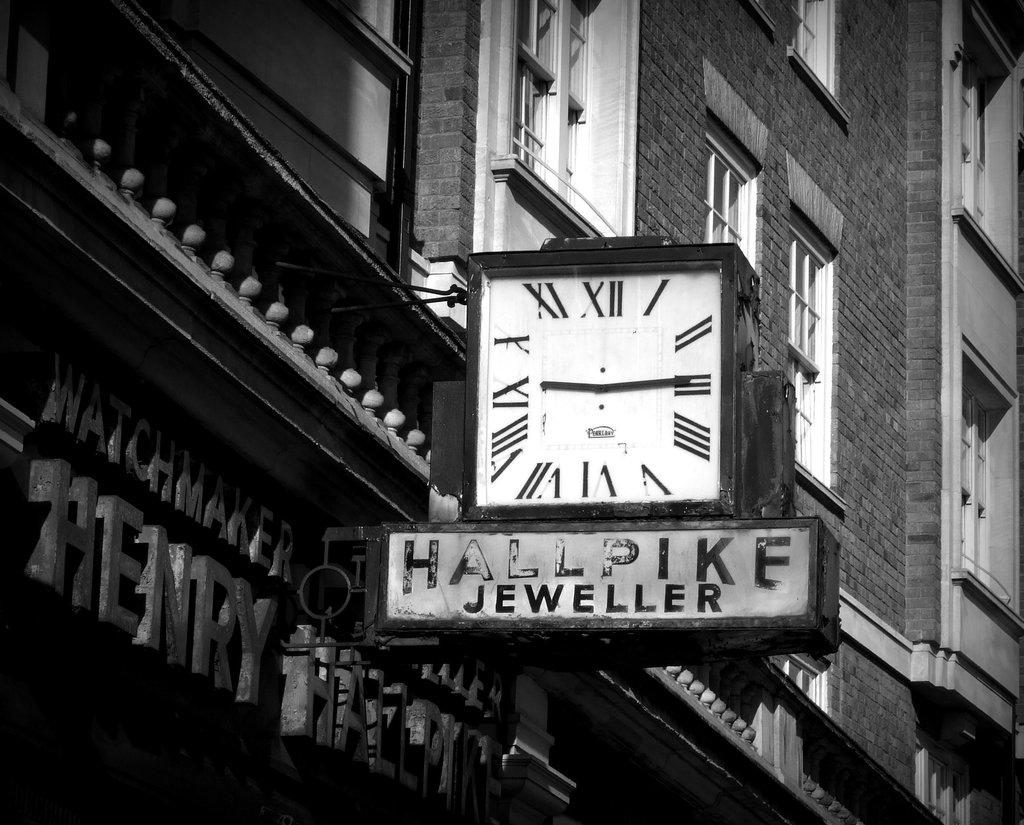<image>
Render a clear and concise summary of the photo. A clock from Hallpike Jeweller hangs out over the sidewalk. 